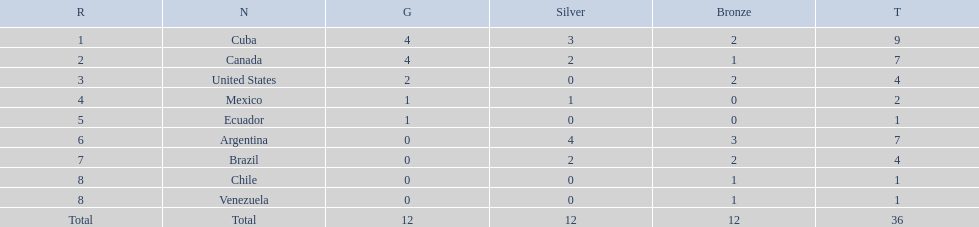Which country won the largest haul of bronze medals? Argentina. 